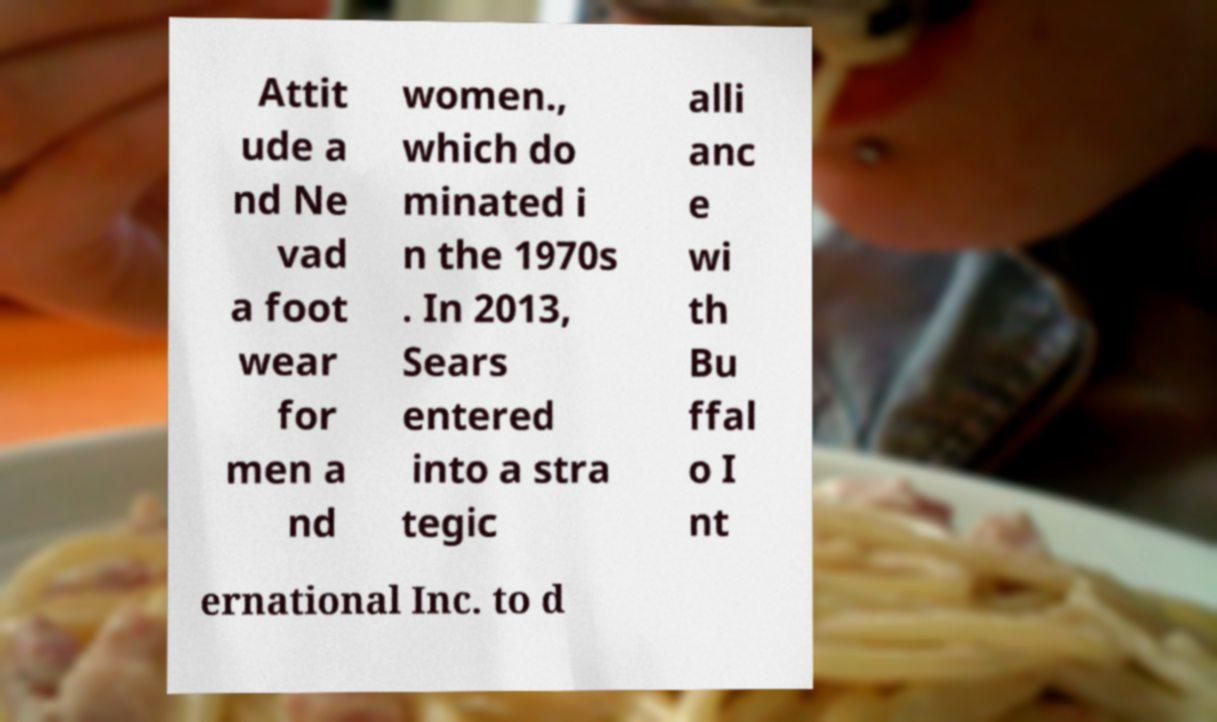Please identify and transcribe the text found in this image. Attit ude a nd Ne vad a foot wear for men a nd women., which do minated i n the 1970s . In 2013, Sears entered into a stra tegic alli anc e wi th Bu ffal o I nt ernational Inc. to d 